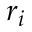Convert formula to latex. <formula><loc_0><loc_0><loc_500><loc_500>r _ { i }</formula> 